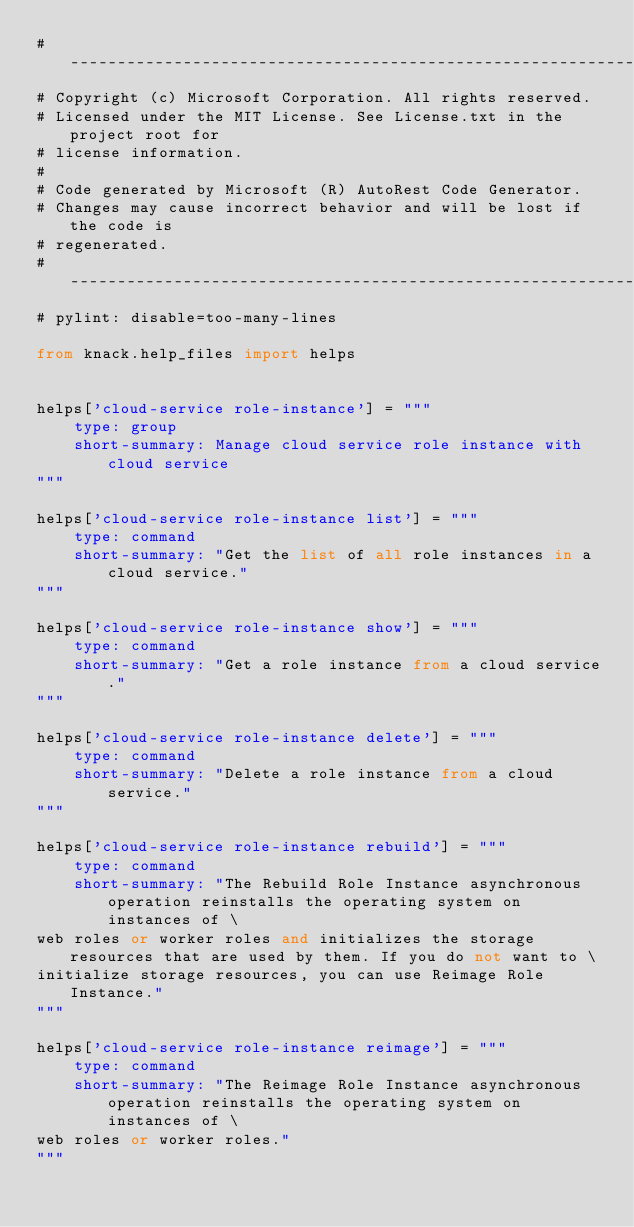<code> <loc_0><loc_0><loc_500><loc_500><_Python_># --------------------------------------------------------------------------
# Copyright (c) Microsoft Corporation. All rights reserved.
# Licensed under the MIT License. See License.txt in the project root for
# license information.
#
# Code generated by Microsoft (R) AutoRest Code Generator.
# Changes may cause incorrect behavior and will be lost if the code is
# regenerated.
# --------------------------------------------------------------------------
# pylint: disable=too-many-lines

from knack.help_files import helps


helps['cloud-service role-instance'] = """
    type: group
    short-summary: Manage cloud service role instance with cloud service
"""

helps['cloud-service role-instance list'] = """
    type: command
    short-summary: "Get the list of all role instances in a cloud service."
"""

helps['cloud-service role-instance show'] = """
    type: command
    short-summary: "Get a role instance from a cloud service."
"""

helps['cloud-service role-instance delete'] = """
    type: command
    short-summary: "Delete a role instance from a cloud service."
"""

helps['cloud-service role-instance rebuild'] = """
    type: command
    short-summary: "The Rebuild Role Instance asynchronous operation reinstalls the operating system on instances of \
web roles or worker roles and initializes the storage resources that are used by them. If you do not want to \
initialize storage resources, you can use Reimage Role Instance."
"""

helps['cloud-service role-instance reimage'] = """
    type: command
    short-summary: "The Reimage Role Instance asynchronous operation reinstalls the operating system on instances of \
web roles or worker roles."
"""
</code> 